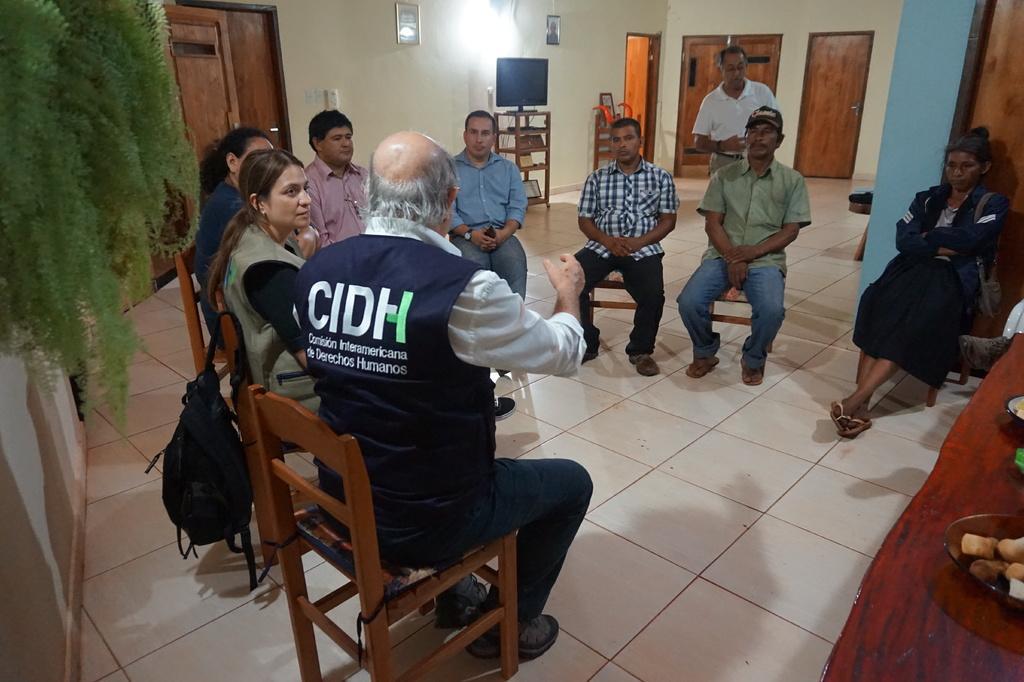Could you give a brief overview of what you see in this image? In this image I can see number of people are sitting on chairs. In the background I can see a man is standing. Here I can see a television and few frames on this wall. 